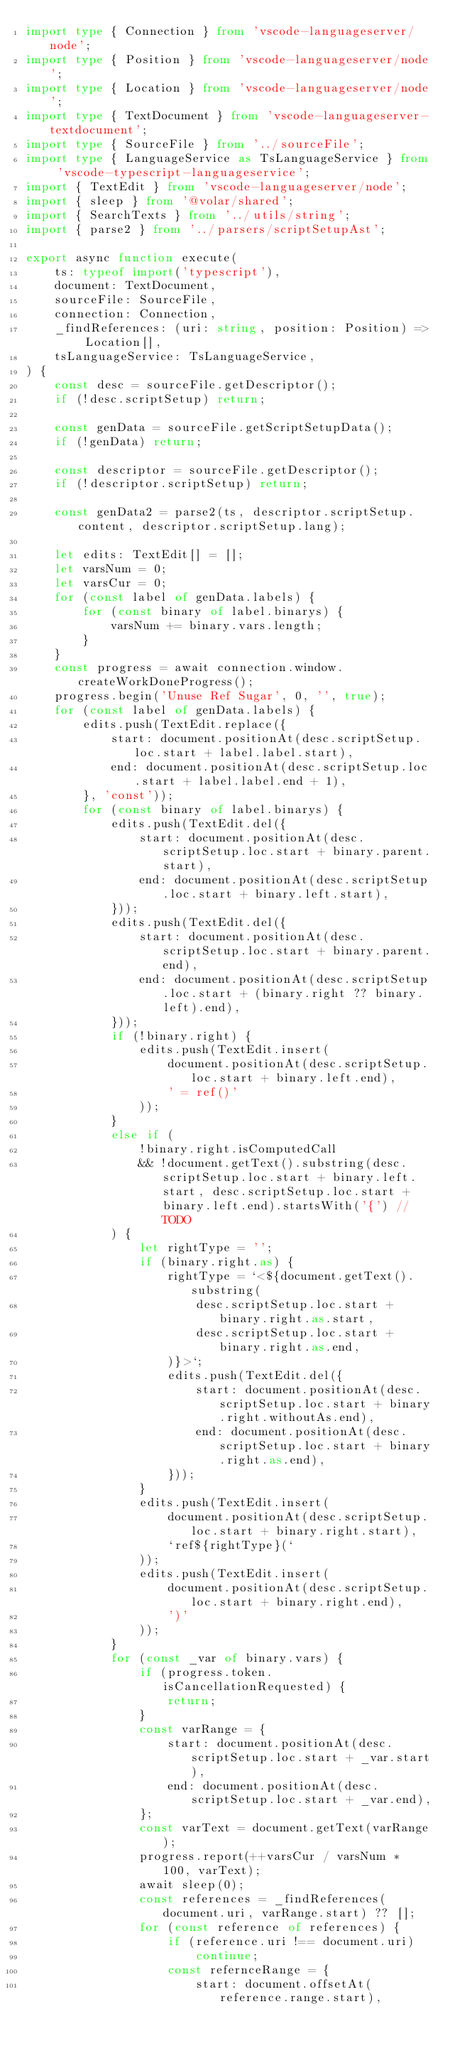Convert code to text. <code><loc_0><loc_0><loc_500><loc_500><_TypeScript_>import type { Connection } from 'vscode-languageserver/node';
import type { Position } from 'vscode-languageserver/node';
import type { Location } from 'vscode-languageserver/node';
import type { TextDocument } from 'vscode-languageserver-textdocument';
import type { SourceFile } from '../sourceFile';
import type { LanguageService as TsLanguageService } from 'vscode-typescript-languageservice';
import { TextEdit } from 'vscode-languageserver/node';
import { sleep } from '@volar/shared';
import { SearchTexts } from '../utils/string';
import { parse2 } from '../parsers/scriptSetupAst';

export async function execute(
    ts: typeof import('typescript'),
    document: TextDocument,
    sourceFile: SourceFile,
    connection: Connection,
    _findReferences: (uri: string, position: Position) => Location[],
    tsLanguageService: TsLanguageService,
) {
    const desc = sourceFile.getDescriptor();
    if (!desc.scriptSetup) return;

    const genData = sourceFile.getScriptSetupData();
    if (!genData) return;

    const descriptor = sourceFile.getDescriptor();
    if (!descriptor.scriptSetup) return;

    const genData2 = parse2(ts, descriptor.scriptSetup.content, descriptor.scriptSetup.lang);

    let edits: TextEdit[] = [];
    let varsNum = 0;
    let varsCur = 0;
    for (const label of genData.labels) {
        for (const binary of label.binarys) {
            varsNum += binary.vars.length;
        }
    }
    const progress = await connection.window.createWorkDoneProgress();
    progress.begin('Unuse Ref Sugar', 0, '', true);
    for (const label of genData.labels) {
        edits.push(TextEdit.replace({
            start: document.positionAt(desc.scriptSetup.loc.start + label.label.start),
            end: document.positionAt(desc.scriptSetup.loc.start + label.label.end + 1),
        }, 'const'));
        for (const binary of label.binarys) {
            edits.push(TextEdit.del({
                start: document.positionAt(desc.scriptSetup.loc.start + binary.parent.start),
                end: document.positionAt(desc.scriptSetup.loc.start + binary.left.start),
            }));
            edits.push(TextEdit.del({
                start: document.positionAt(desc.scriptSetup.loc.start + binary.parent.end),
                end: document.positionAt(desc.scriptSetup.loc.start + (binary.right ?? binary.left).end),
            }));
            if (!binary.right) {
                edits.push(TextEdit.insert(
                    document.positionAt(desc.scriptSetup.loc.start + binary.left.end),
                    ' = ref()'
                ));
            }
            else if (
                !binary.right.isComputedCall
                && !document.getText().substring(desc.scriptSetup.loc.start + binary.left.start, desc.scriptSetup.loc.start + binary.left.end).startsWith('{') // TODO
            ) {
                let rightType = '';
                if (binary.right.as) {
                    rightType = `<${document.getText().substring(
                        desc.scriptSetup.loc.start + binary.right.as.start,
                        desc.scriptSetup.loc.start + binary.right.as.end,
                    )}>`;
                    edits.push(TextEdit.del({
                        start: document.positionAt(desc.scriptSetup.loc.start + binary.right.withoutAs.end),
                        end: document.positionAt(desc.scriptSetup.loc.start + binary.right.as.end),
                    }));
                }
                edits.push(TextEdit.insert(
                    document.positionAt(desc.scriptSetup.loc.start + binary.right.start),
                    `ref${rightType}(`
                ));
                edits.push(TextEdit.insert(
                    document.positionAt(desc.scriptSetup.loc.start + binary.right.end),
                    ')'
                ));
            }
            for (const _var of binary.vars) {
                if (progress.token.isCancellationRequested) {
                    return;
                }
                const varRange = {
                    start: document.positionAt(desc.scriptSetup.loc.start + _var.start),
                    end: document.positionAt(desc.scriptSetup.loc.start + _var.end),
                };
                const varText = document.getText(varRange);
                progress.report(++varsCur / varsNum * 100, varText);
                await sleep(0);
                const references = _findReferences(document.uri, varRange.start) ?? [];
                for (const reference of references) {
                    if (reference.uri !== document.uri)
                        continue;
                    const refernceRange = {
                        start: document.offsetAt(reference.range.start),</code> 